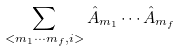Convert formula to latex. <formula><loc_0><loc_0><loc_500><loc_500>\sum _ { < m _ { 1 } \cdots m _ { f } , i > } \hat { A } _ { m _ { 1 } } \cdots \hat { A } _ { m _ { f } }</formula> 